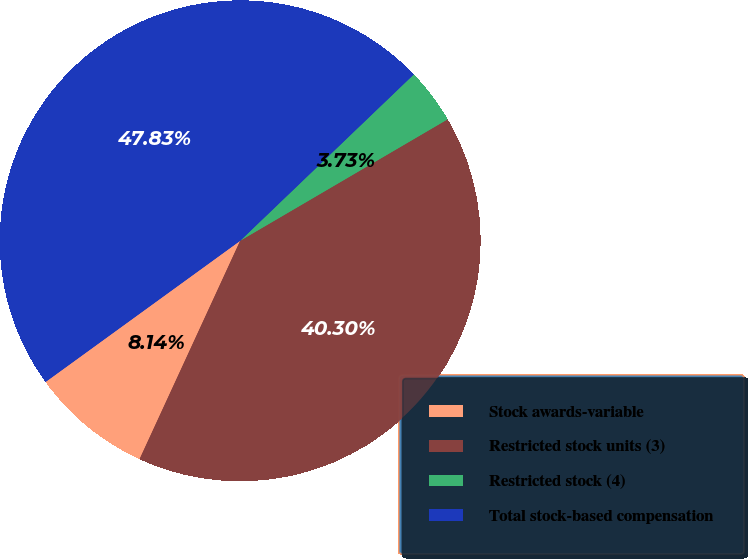Convert chart to OTSL. <chart><loc_0><loc_0><loc_500><loc_500><pie_chart><fcel>Stock awards-variable<fcel>Restricted stock units (3)<fcel>Restricted stock (4)<fcel>Total stock-based compensation<nl><fcel>8.14%<fcel>40.3%<fcel>3.73%<fcel>47.83%<nl></chart> 